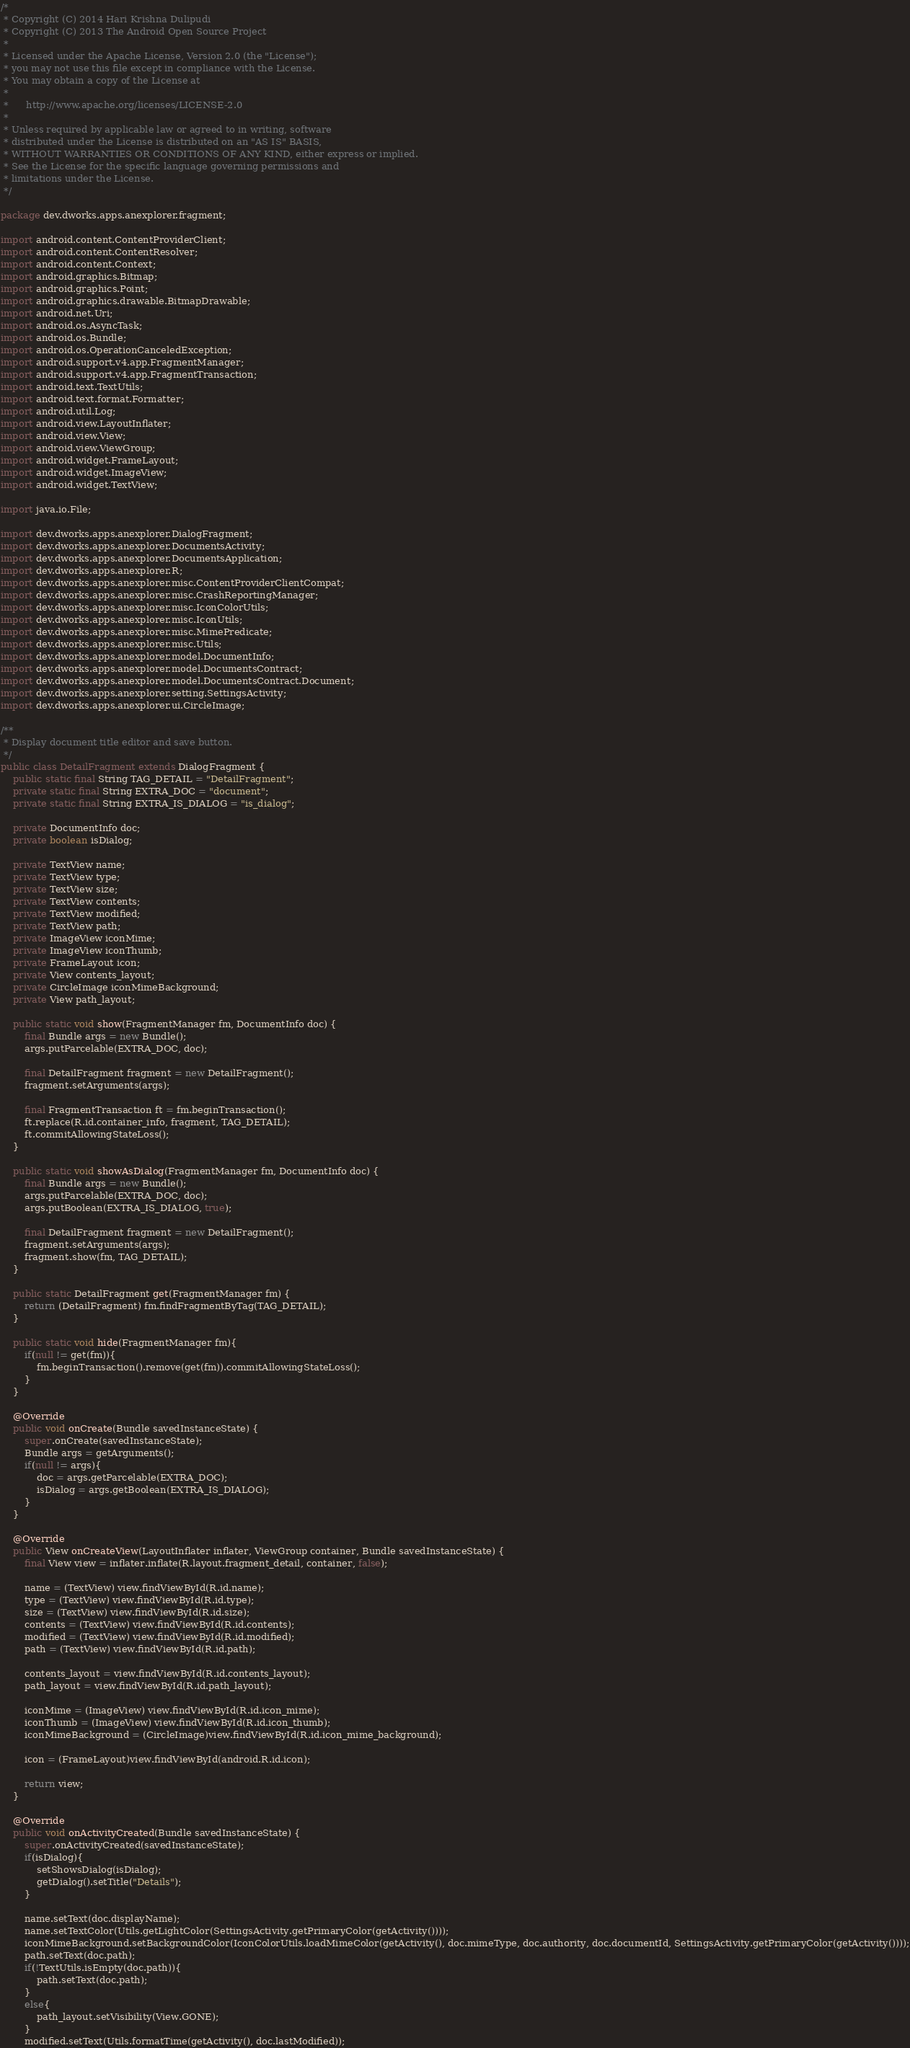<code> <loc_0><loc_0><loc_500><loc_500><_Java_>/*
 * Copyright (C) 2014 Hari Krishna Dulipudi
 * Copyright (C) 2013 The Android Open Source Project
 *
 * Licensed under the Apache License, Version 2.0 (the "License");
 * you may not use this file except in compliance with the License.
 * You may obtain a copy of the License at
 *
 *      http://www.apache.org/licenses/LICENSE-2.0
 *
 * Unless required by applicable law or agreed to in writing, software
 * distributed under the License is distributed on an "AS IS" BASIS,
 * WITHOUT WARRANTIES OR CONDITIONS OF ANY KIND, either express or implied.
 * See the License for the specific language governing permissions and
 * limitations under the License.
 */

package dev.dworks.apps.anexplorer.fragment;

import android.content.ContentProviderClient;
import android.content.ContentResolver;
import android.content.Context;
import android.graphics.Bitmap;
import android.graphics.Point;
import android.graphics.drawable.BitmapDrawable;
import android.net.Uri;
import android.os.AsyncTask;
import android.os.Bundle;
import android.os.OperationCanceledException;
import android.support.v4.app.FragmentManager;
import android.support.v4.app.FragmentTransaction;
import android.text.TextUtils;
import android.text.format.Formatter;
import android.util.Log;
import android.view.LayoutInflater;
import android.view.View;
import android.view.ViewGroup;
import android.widget.FrameLayout;
import android.widget.ImageView;
import android.widget.TextView;

import java.io.File;

import dev.dworks.apps.anexplorer.DialogFragment;
import dev.dworks.apps.anexplorer.DocumentsActivity;
import dev.dworks.apps.anexplorer.DocumentsApplication;
import dev.dworks.apps.anexplorer.R;
import dev.dworks.apps.anexplorer.misc.ContentProviderClientCompat;
import dev.dworks.apps.anexplorer.misc.CrashReportingManager;
import dev.dworks.apps.anexplorer.misc.IconColorUtils;
import dev.dworks.apps.anexplorer.misc.IconUtils;
import dev.dworks.apps.anexplorer.misc.MimePredicate;
import dev.dworks.apps.anexplorer.misc.Utils;
import dev.dworks.apps.anexplorer.model.DocumentInfo;
import dev.dworks.apps.anexplorer.model.DocumentsContract;
import dev.dworks.apps.anexplorer.model.DocumentsContract.Document;
import dev.dworks.apps.anexplorer.setting.SettingsActivity;
import dev.dworks.apps.anexplorer.ui.CircleImage;

/**
 * Display document title editor and save button.
 */
public class DetailFragment extends DialogFragment {
	public static final String TAG_DETAIL = "DetailFragment";
	private static final String EXTRA_DOC = "document";
	private static final String EXTRA_IS_DIALOG = "is_dialog";
	
	private DocumentInfo doc;
	private boolean isDialog;
	
	private TextView name;
	private TextView type;
	private TextView size;
	private TextView contents;
	private TextView modified;
	private TextView path;
	private ImageView iconMime;
	private ImageView iconThumb;
	private FrameLayout icon;
	private View contents_layout;
    private CircleImage iconMimeBackground;
    private View path_layout;

    public static void show(FragmentManager fm, DocumentInfo doc) {
		final Bundle args = new Bundle();
		args.putParcelable(EXTRA_DOC, doc);
		
		final DetailFragment fragment = new DetailFragment();
		fragment.setArguments(args);

		final FragmentTransaction ft = fm.beginTransaction();
		ft.replace(R.id.container_info, fragment, TAG_DETAIL);
		ft.commitAllowingStateLoss();
	}

    public static void showAsDialog(FragmentManager fm, DocumentInfo doc) {
		final Bundle args = new Bundle();
		args.putParcelable(EXTRA_DOC, doc);
		args.putBoolean(EXTRA_IS_DIALOG, true);
		
		final DetailFragment fragment = new DetailFragment();
		fragment.setArguments(args);
		fragment.show(fm, TAG_DETAIL);
    }
        
	public static DetailFragment get(FragmentManager fm) {
		return (DetailFragment) fm.findFragmentByTag(TAG_DETAIL);
	}
	
	public static void hide(FragmentManager fm){
		if(null != get(fm)){
			fm.beginTransaction().remove(get(fm)).commitAllowingStateLoss();
		}
	}

	@Override
	public void onCreate(Bundle savedInstanceState) {
		super.onCreate(savedInstanceState);
		Bundle args = getArguments();
		if(null != args){
			doc = args.getParcelable(EXTRA_DOC);
			isDialog = args.getBoolean(EXTRA_IS_DIALOG);
		}
	}
	
	@Override
	public View onCreateView(LayoutInflater inflater, ViewGroup container, Bundle savedInstanceState) {
		final View view = inflater.inflate(R.layout.fragment_detail, container, false);

		name = (TextView) view.findViewById(R.id.name);
		type = (TextView) view.findViewById(R.id.type);
		size = (TextView) view.findViewById(R.id.size);
		contents = (TextView) view.findViewById(R.id.contents);
		modified = (TextView) view.findViewById(R.id.modified);
		path = (TextView) view.findViewById(R.id.path);
		
		contents_layout = view.findViewById(R.id.contents_layout);
		path_layout = view.findViewById(R.id.path_layout);

		iconMime = (ImageView) view.findViewById(R.id.icon_mime);
		iconThumb = (ImageView) view.findViewById(R.id.icon_thumb);
        iconMimeBackground = (CircleImage)view.findViewById(R.id.icon_mime_background);

		icon = (FrameLayout)view.findViewById(android.R.id.icon);
		
		return view;
	}

	@Override
	public void onActivityCreated(Bundle savedInstanceState) {
		super.onActivityCreated(savedInstanceState);
		if(isDialog){
            setShowsDialog(isDialog);
			getDialog().setTitle("Details");
		}
		
		name.setText(doc.displayName);
        name.setTextColor(Utils.getLightColor(SettingsActivity.getPrimaryColor(getActivity())));
        iconMimeBackground.setBackgroundColor(IconColorUtils.loadMimeColor(getActivity(), doc.mimeType, doc.authority, doc.documentId, SettingsActivity.getPrimaryColor(getActivity())));
		path.setText(doc.path);
        if(!TextUtils.isEmpty(doc.path)){
            path.setText(doc.path);
        }
        else{
            path_layout.setVisibility(View.GONE);
        }
		modified.setText(Utils.formatTime(getActivity(), doc.lastModified));</code> 